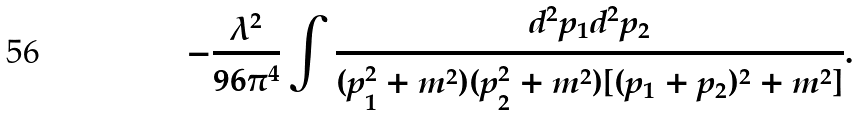<formula> <loc_0><loc_0><loc_500><loc_500>- \frac { \lambda ^ { 2 } } { 9 6 \pi ^ { 4 } } \int \frac { d ^ { 2 } { p } _ { 1 } d ^ { 2 } { p } _ { 2 } } { ( p _ { 1 } ^ { 2 } + m ^ { 2 } ) ( p _ { 2 } ^ { 2 } + m ^ { 2 } ) [ ( { p } _ { 1 } + { p } _ { 2 } ) ^ { 2 } + m ^ { 2 } ] } .</formula> 